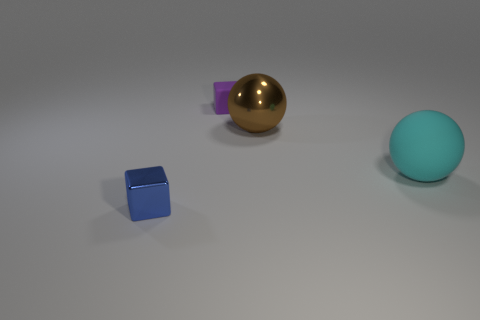There is a rubber thing that is behind the brown metal ball; does it have the same size as the metallic thing that is to the right of the blue metal thing?
Your response must be concise. No. What is the object that is left of the cyan sphere and in front of the big brown metallic sphere made of?
Keep it short and to the point. Metal. What number of other things are the same size as the purple rubber cube?
Keep it short and to the point. 1. What is the big ball in front of the large brown object made of?
Provide a short and direct response. Rubber. Is the shape of the small purple thing the same as the brown object?
Offer a very short reply. No. What number of other objects are there of the same shape as the brown thing?
Make the answer very short. 1. There is a small object that is behind the blue shiny thing; what color is it?
Offer a very short reply. Purple. Do the brown shiny thing and the cyan matte ball have the same size?
Make the answer very short. Yes. What material is the big thing that is on the right side of the large sphere that is behind the large matte ball?
Make the answer very short. Rubber. How many tiny rubber cubes are the same color as the big metallic sphere?
Offer a very short reply. 0. 